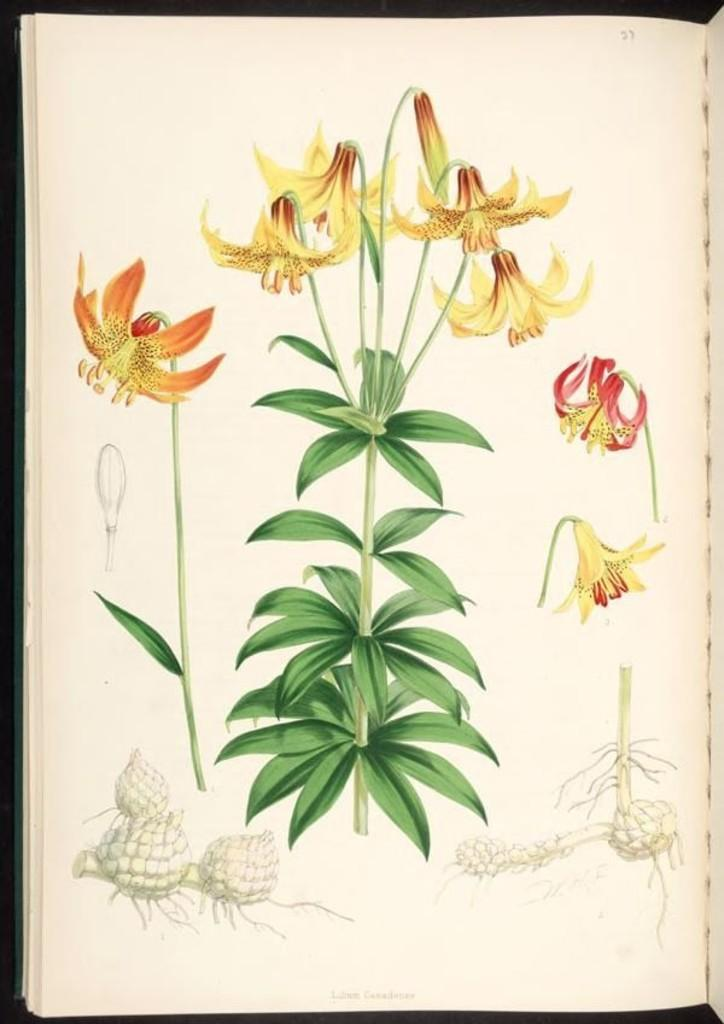What is featured on the poster in the image? The poster contains plants and flowers. Can you describe the content of the poster in more detail? The bottom of the poster shows parts of plants. How many passengers are visible on the poster? There are no passengers present on the poster; it features plants and flowers. What direction is the wind blowing in the image? There is no wind depicted in the image; it only shows a poster with plants and flowers. 